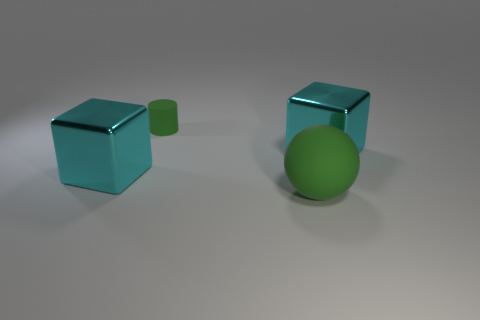Add 2 rubber things. How many objects exist? 6 Subtract all cylinders. How many objects are left? 3 Add 1 green matte spheres. How many green matte spheres exist? 2 Subtract 0 red cylinders. How many objects are left? 4 Subtract all small rubber objects. Subtract all green rubber balls. How many objects are left? 2 Add 4 matte objects. How many matte objects are left? 6 